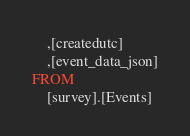<code> <loc_0><loc_0><loc_500><loc_500><_SQL_>	,[createdutc]
	,[event_data_json]
FROM
	[survey].[Events]</code> 